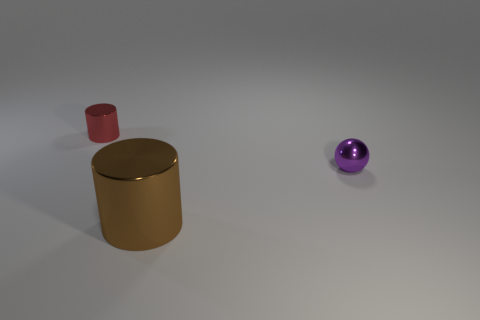Add 3 small cylinders. How many objects exist? 6 Subtract all balls. How many objects are left? 2 Subtract all small gray cubes. Subtract all red shiny things. How many objects are left? 2 Add 1 big metal things. How many big metal things are left? 2 Add 1 tiny red matte cylinders. How many tiny red matte cylinders exist? 1 Subtract 0 blue cubes. How many objects are left? 3 